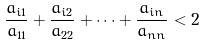<formula> <loc_0><loc_0><loc_500><loc_500>\frac { a _ { i 1 } } { a _ { 1 1 } } + \frac { a _ { i 2 } } { a _ { 2 2 } } + \cdots + \frac { a _ { i n } } { a _ { n n } } < 2</formula> 